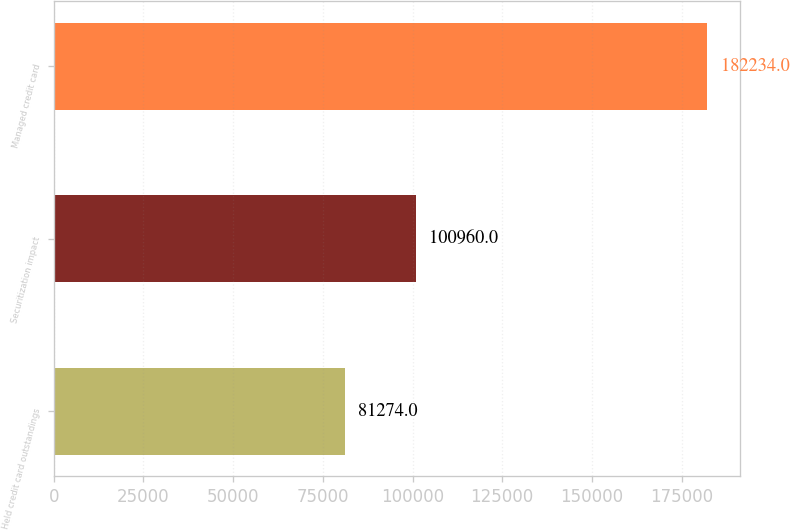<chart> <loc_0><loc_0><loc_500><loc_500><bar_chart><fcel>Held credit card outstandings<fcel>Securitization impact<fcel>Managed credit card<nl><fcel>81274<fcel>100960<fcel>182234<nl></chart> 